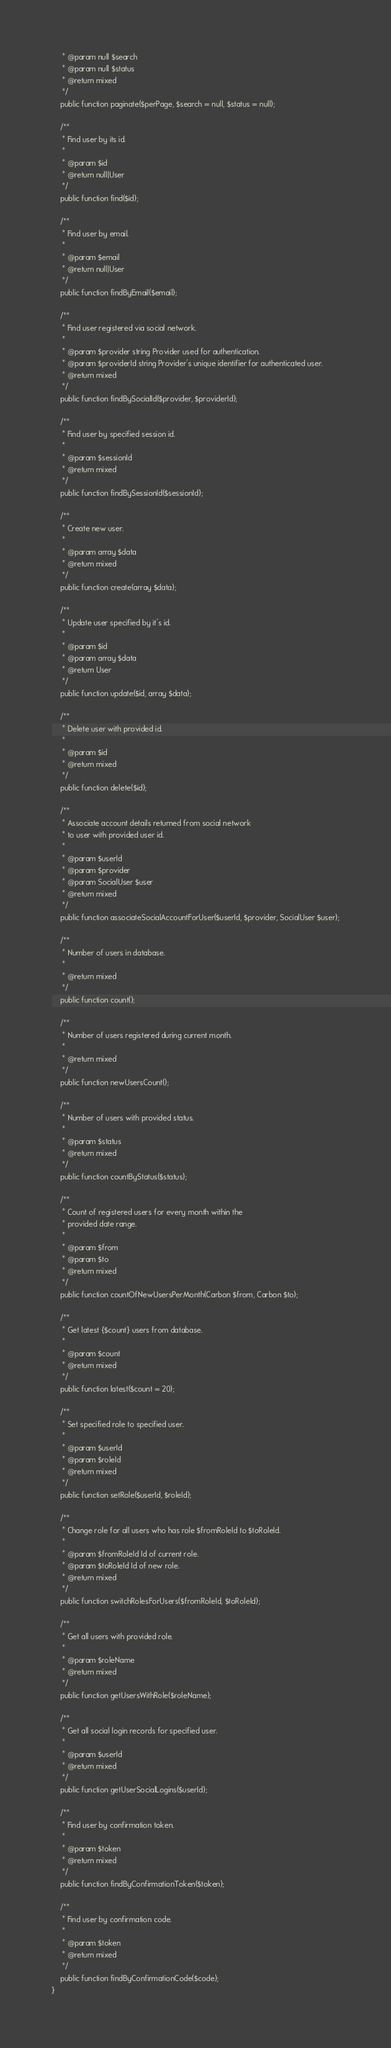<code> <loc_0><loc_0><loc_500><loc_500><_PHP_>     * @param null $search
     * @param null $status
     * @return mixed
     */
    public function paginate($perPage, $search = null, $status = null);

    /**
     * Find user by its id.
     *
     * @param $id
     * @return null|User
     */
    public function find($id);

    /**
     * Find user by email.
     *
     * @param $email
     * @return null|User
     */
    public function findByEmail($email);

    /**
     * Find user registered via social network.
     *
     * @param $provider string Provider used for authentication.
     * @param $providerId string Provider's unique identifier for authenticated user.
     * @return mixed
     */
    public function findBySocialId($provider, $providerId);

    /**
     * Find user by specified session id.
     *
     * @param $sessionId
     * @return mixed
     */
    public function findBySessionId($sessionId);

    /**
     * Create new user.
     *
     * @param array $data
     * @return mixed
     */
    public function create(array $data);

    /**
     * Update user specified by it's id.
     *
     * @param $id
     * @param array $data
     * @return User
     */
    public function update($id, array $data);

    /**
     * Delete user with provided id.
     *
     * @param $id
     * @return mixed
     */
    public function delete($id);

    /**
     * Associate account details returned from social network
     * to user with provided user id.
     *
     * @param $userId
     * @param $provider
     * @param SocialUser $user
     * @return mixed
     */
    public function associateSocialAccountForUser($userId, $provider, SocialUser $user);

    /**
     * Number of users in database.
     *
     * @return mixed
     */
    public function count();

    /**
     * Number of users registered during current month.
     *
     * @return mixed
     */
    public function newUsersCount();

    /**
     * Number of users with provided status.
     *
     * @param $status
     * @return mixed
     */
    public function countByStatus($status);

    /**
     * Count of registered users for every month within the
     * provided date range.
     *
     * @param $from
     * @param $to
     * @return mixed
     */
    public function countOfNewUsersPerMonth(Carbon $from, Carbon $to);

    /**
     * Get latest {$count} users from database.
     *
     * @param $count
     * @return mixed
     */
    public function latest($count = 20);

    /**
     * Set specified role to specified user.
     *
     * @param $userId
     * @param $roleId
     * @return mixed
     */
    public function setRole($userId, $roleId);

    /**
     * Change role for all users who has role $fromRoleId to $toRoleId.
     *
     * @param $fromRoleId Id of current role.
     * @param $toRoleId Id of new role.
     * @return mixed
     */
    public function switchRolesForUsers($fromRoleId, $toRoleId);

    /**
     * Get all users with provided role.
     *
     * @param $roleName
     * @return mixed
     */
    public function getUsersWithRole($roleName);

    /**
     * Get all social login records for specified user.
     *
     * @param $userId
     * @return mixed
     */
    public function getUserSocialLogins($userId);

    /**
     * Find user by confirmation token.
     *
     * @param $token
     * @return mixed
     */
    public function findByConfirmationToken($token);

    /**
     * Find user by confirmation code.
     *
     * @param $token
     * @return mixed
     */
    public function findByConfirmationCode($code);
}</code> 